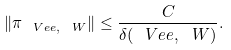<formula> <loc_0><loc_0><loc_500><loc_500>\| \pi _ { \ V e e , \ W } \| \leq \frac { C } { \delta ( \ V e e , \ W ) } .</formula> 